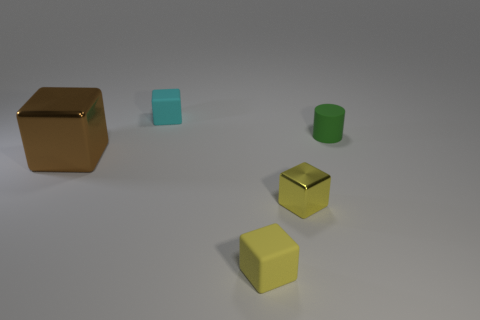There is a rubber object that is both behind the brown block and in front of the cyan matte object; what size is it?
Your answer should be compact. Small. What number of small things are metallic objects or brown shiny cubes?
Give a very brief answer. 1. What is the shape of the tiny matte thing that is behind the small cylinder?
Your answer should be very brief. Cube. What number of small rubber objects are there?
Ensure brevity in your answer.  3. Does the small cyan block have the same material as the brown thing?
Your response must be concise. No. Are there more brown metallic cubes that are in front of the big brown object than rubber cylinders?
Give a very brief answer. No. What number of things are either tiny shiny things or things on the right side of the brown metal block?
Make the answer very short. 4. Are there more small things behind the large brown metallic object than small matte things that are on the left side of the tiny green cylinder?
Provide a short and direct response. No. There is a small block behind the object that is to the left of the cube behind the tiny rubber cylinder; what is its material?
Offer a very short reply. Rubber. The small cyan thing that is the same material as the small green cylinder is what shape?
Your answer should be very brief. Cube. 